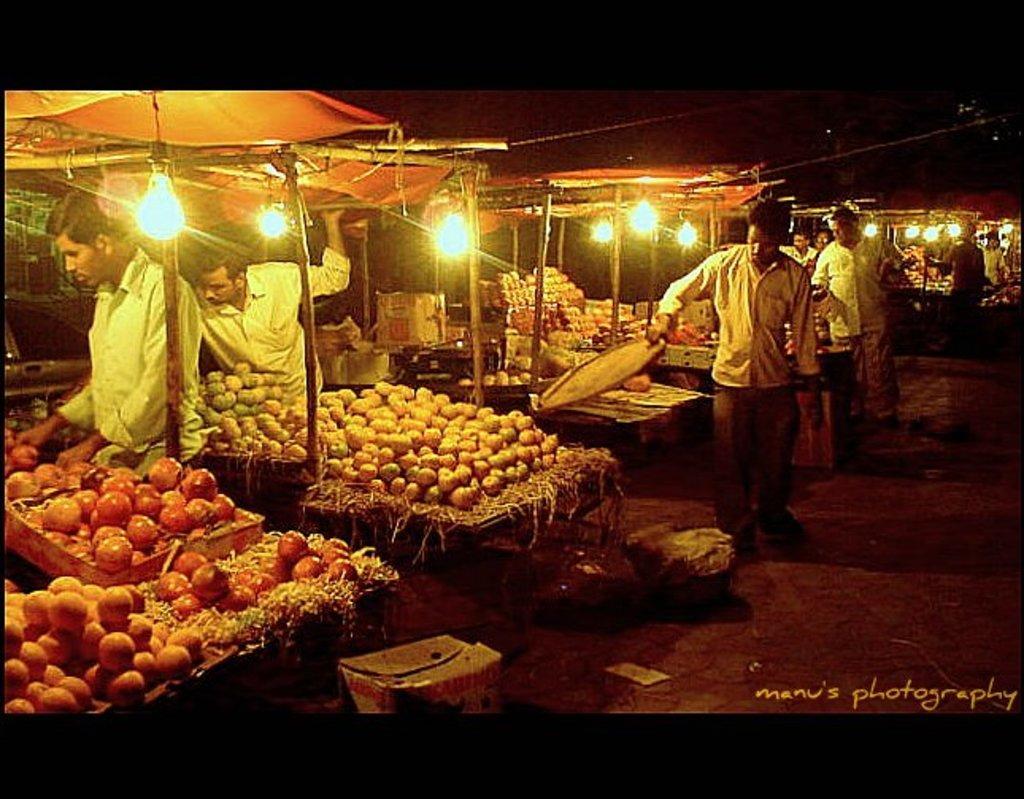How would you summarize this image in a sentence or two? In this picture, we can see a few people, and a few are holding some objects, we can see the ground and some objects on the ground like boxes, we can see some sheds, and some objects like wooden trays, fruits, lights, poles, and we can see the dark sky, some watermark on the bottom right side of the picture. 